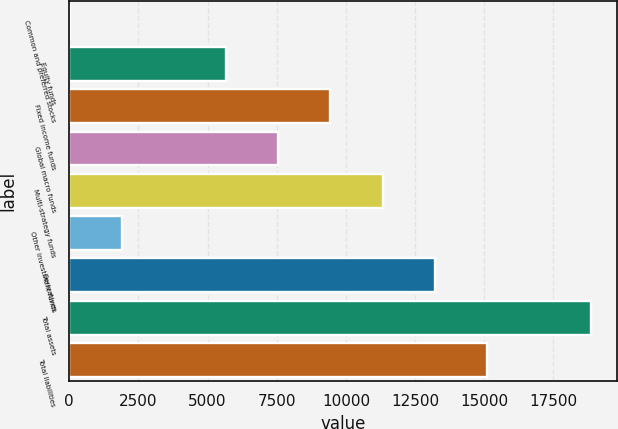<chart> <loc_0><loc_0><loc_500><loc_500><bar_chart><fcel>Common and preferred stocks<fcel>Equity funds<fcel>Fixed income funds<fcel>Global macro funds<fcel>Multi-strategy funds<fcel>Other investment funds<fcel>Derivatives<fcel>Total assets<fcel>Total liabilities<nl><fcel>8<fcel>5668.1<fcel>9441.5<fcel>7554.8<fcel>11328.2<fcel>1894.7<fcel>13214.9<fcel>18875<fcel>15101.6<nl></chart> 